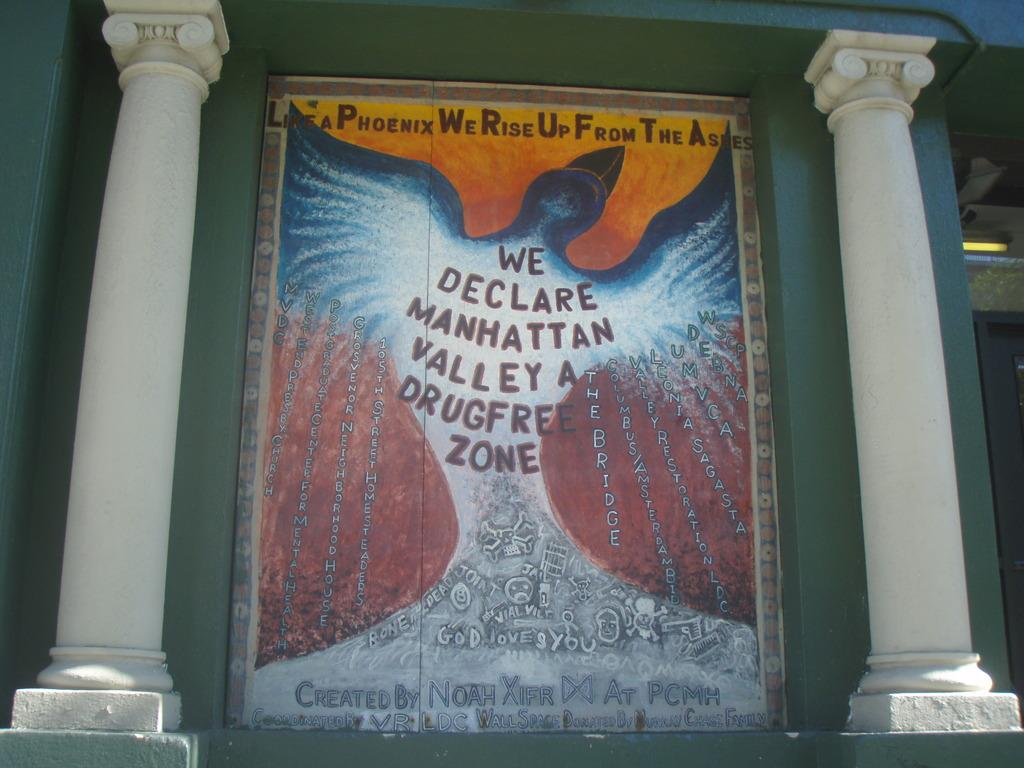<image>
Give a short and clear explanation of the subsequent image. A banner between two pillars proclaims, "We declare Manhattan Valley a drugfree zone." 